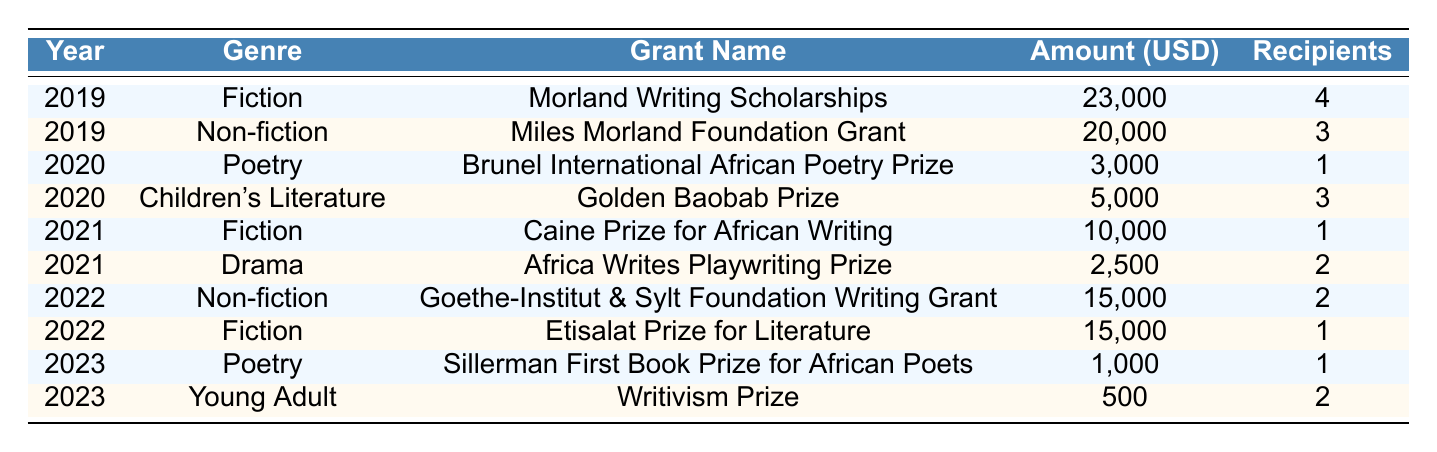What was the total amount awarded in grants for Fiction in 2019? In 2019, there was one grant for Fiction: Morland Writing Scholarships, which amounted to 23,000 USD. Therefore, the total amount awarded for Fiction in that year is 23,000 USD.
Answer: 23,000 USD How many total grants were awarded in 2022? In 2022, there were two grants awarded: one for Non-fiction (Goethe-Institut & Sylt Foundation Writing Grant) and one for Fiction (Etisalat Prize for Literature). Therefore, the total number of grants awarded in 2022 is 2.
Answer: 2 Which genre received the highest amount in grants in 2019? In 2019, the Fiction genre received 23,000 USD from the Morland Writing Scholarships, while Non-fiction received 20,000 USD from the Miles Morland Foundation Grant. Fiction had the highest amount of 23,000 USD in 2019.
Answer: Fiction What is the average grant amount awarded to Drama and Poetry combined for the year 2021? For the year 2021, Drama (Africa Writes Playwriting Prize) received 2,500 USD and Poetry was not awarded; therefore, the average is calculated as (2,500 + 0) / 2 = 1,250 USD.
Answer: 1,250 USD Did any of the grant recipients in 2023 receive more than 1,000 USD? In 2023, the Sillerman First Book Prize for African Poets awarded 1,000 USD, and the Writivism Prize awarded 500 USD. Since the Writivism Prize is less than 1,000 USD, the answer is yes; there was one grant equal to 1,000 USD.
Answer: Yes Which year had the highest number of recipients in Children's Literature, and how many were there? Children's Literature was funded in 2020 with 3 recipients for the Golden Baobab Prize. This is the only occurrence listed for this genre across the years, therefore it has the highest number of recipients at 3 in 2020.
Answer: 2020, 3 recipients What was the difference in the amount awarded to Non-fiction between 2019 and 2022? In 2019, Non-fiction received 20,000 USD, while in 2022, it received 15,000 USD. The difference is 20,000 - 15,000 = 5,000 USD.
Answer: 5,000 USD What genres were awarded grants in the year 2020? In 2020, grants were awarded for two genres: Poetry (Brunel International African Poetry Prize) and Children's Literature (Golden Baobab Prize). The genres are Poetry and Children's Literature.
Answer: Poetry and Children's Literature Which genre had the least total amount awarded across all years? The grant awarded for Young Adult in 2023 (Writivism Prize) was 500 USD, and every other awarded genre received more than this amount in their respective years. Hence, the least total amount awarded is for Young Adult.
Answer: Young Adult What is the total number of recipients across all genres for the year 2021? In 2021, there were 1 recipient for Fiction (Caine Prize for African Writing) and 2 recipients for Drama (Africa Writes Playwriting Prize). Summing these gives a total of 1 + 2 = 3 recipients in 2021.
Answer: 3 recipients 